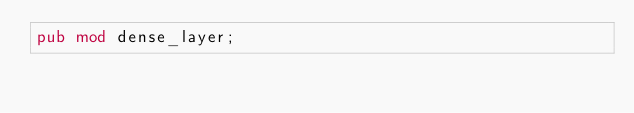<code> <loc_0><loc_0><loc_500><loc_500><_Rust_>pub mod dense_layer;
</code> 